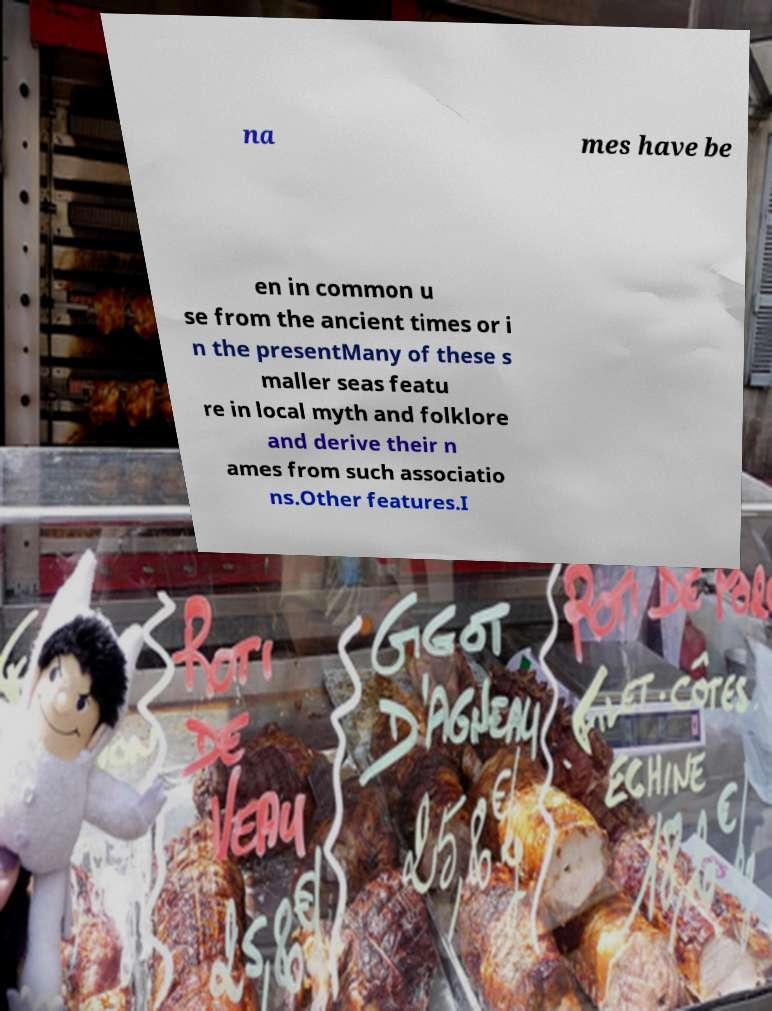Please read and relay the text visible in this image. What does it say? na mes have be en in common u se from the ancient times or i n the presentMany of these s maller seas featu re in local myth and folklore and derive their n ames from such associatio ns.Other features.I 